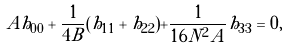<formula> <loc_0><loc_0><loc_500><loc_500>A h _ { 0 0 } + \frac { 1 } { 4 B } ( h _ { 1 1 } + h _ { 2 2 } ) + \frac { 1 } { 1 6 N ^ { 2 } A } h _ { 3 3 } = 0 ,</formula> 